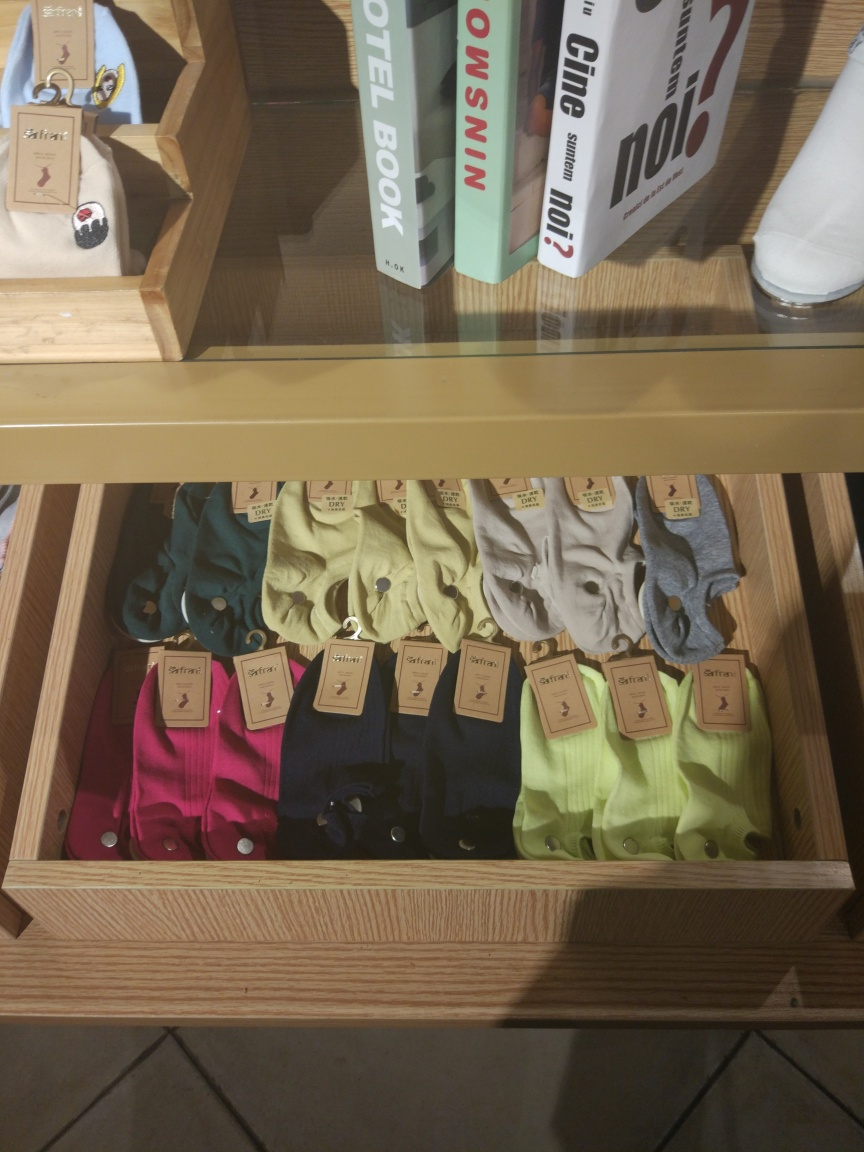Is the overall clarity of the image good?
A. No
B. Yes
Answer with the option's letter from the given choices directly.
 B. 